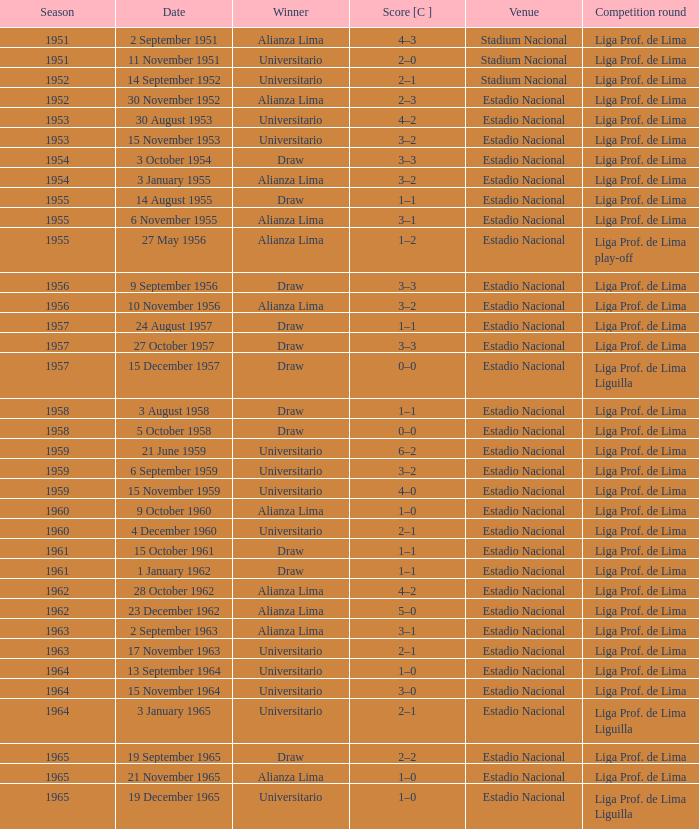What was the outcome in terms of points for the 1965 event won by alianza lima? 1–0. 